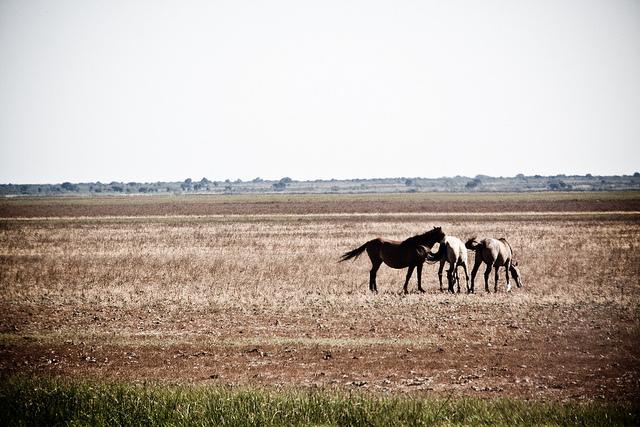What type of excursion could one go on to see these animals?
Be succinct. Safari. Where are the horses?
Write a very short answer. Field. Are there any trees near the horses?
Concise answer only. No. How many horses?
Give a very brief answer. 3. 